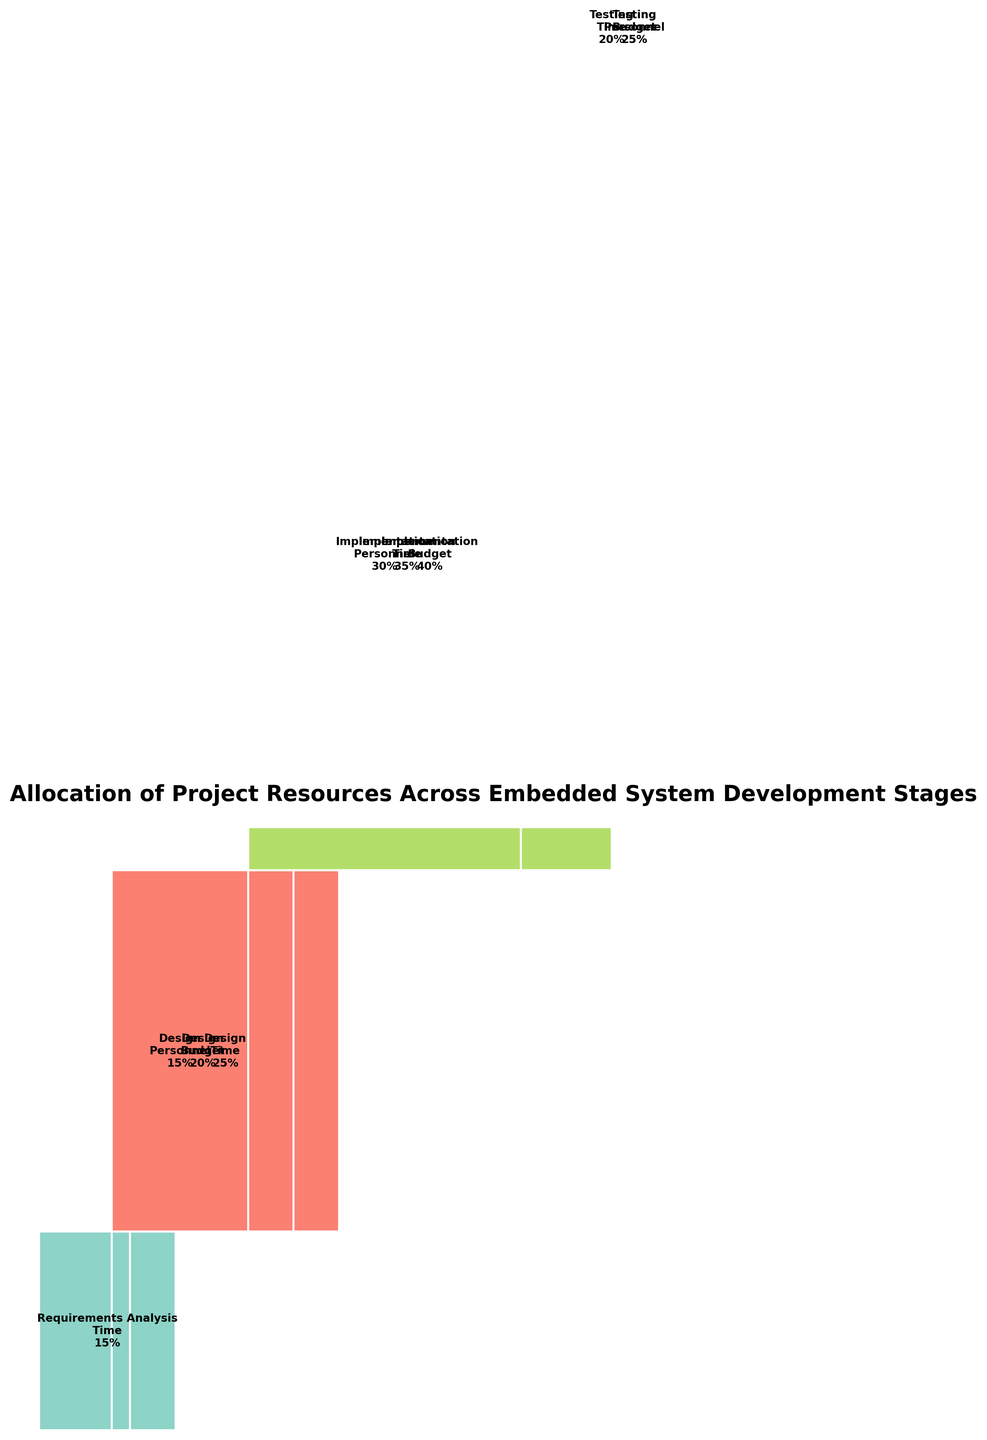What is the title of the mosaic plot? The title is at the top of the figure and describes the main subject of the plot.
Answer: Allocation of Project Resources Across Embedded System Development Stages How many stages are represented in the plot? Each distinct color block represents a stage in the embedded system development. Count the different stages.
Answer: 5 Which stage has the largest allocation of budget? Look at the height of each rectangle labeled with 'Budget' and find the one with the greatest height.
Answer: Implementation Compare the time allocation for Requirements Analysis and Deployment. Which has a higher allocation? Identify the rectangles labeled 'Time' for both 'Requirements Analysis' and 'Deployment', then compare their widths.
Answer: Requirements Analysis What is the total allocation for personnel in the Implementation stage? The total allocation for personnel is labeled within each stage. Look for 'Personnel' in the Implementation stage.
Answer: 30 What is the combined allocation of budget and time in the Testing stage? Find the rectangles labeled 'Time' and 'Budget' in the Testing stage and sum their widths.
Answer: 45 How does the total resource allocation of Testing compare to the total resource allocation of Design? Sum the allocations of Time, Budget, and Personnel for both stages and compare the totals.
Answer: Testing has a total of 70, while Design has a total of 60. Testing has a higher allocation Which stage has the smallest allocation of time, and what is the value? Look for the smallest rectangle labeled 'Time' and identify its value and corresponding stage.
Answer: Deployment, 5 How does the allocation for personnel in Testing compare to that in Deployment? Compare the widths of the rectangles labeled 'Personnel' in Testing and Deployment stages.
Answer: Testing has more allocation (25 vs. 7) Which resource allocation varies the most across the stages? Examine the width of rectangles for each resource across different stages to determine which has the most variation.
Answer: Budget 